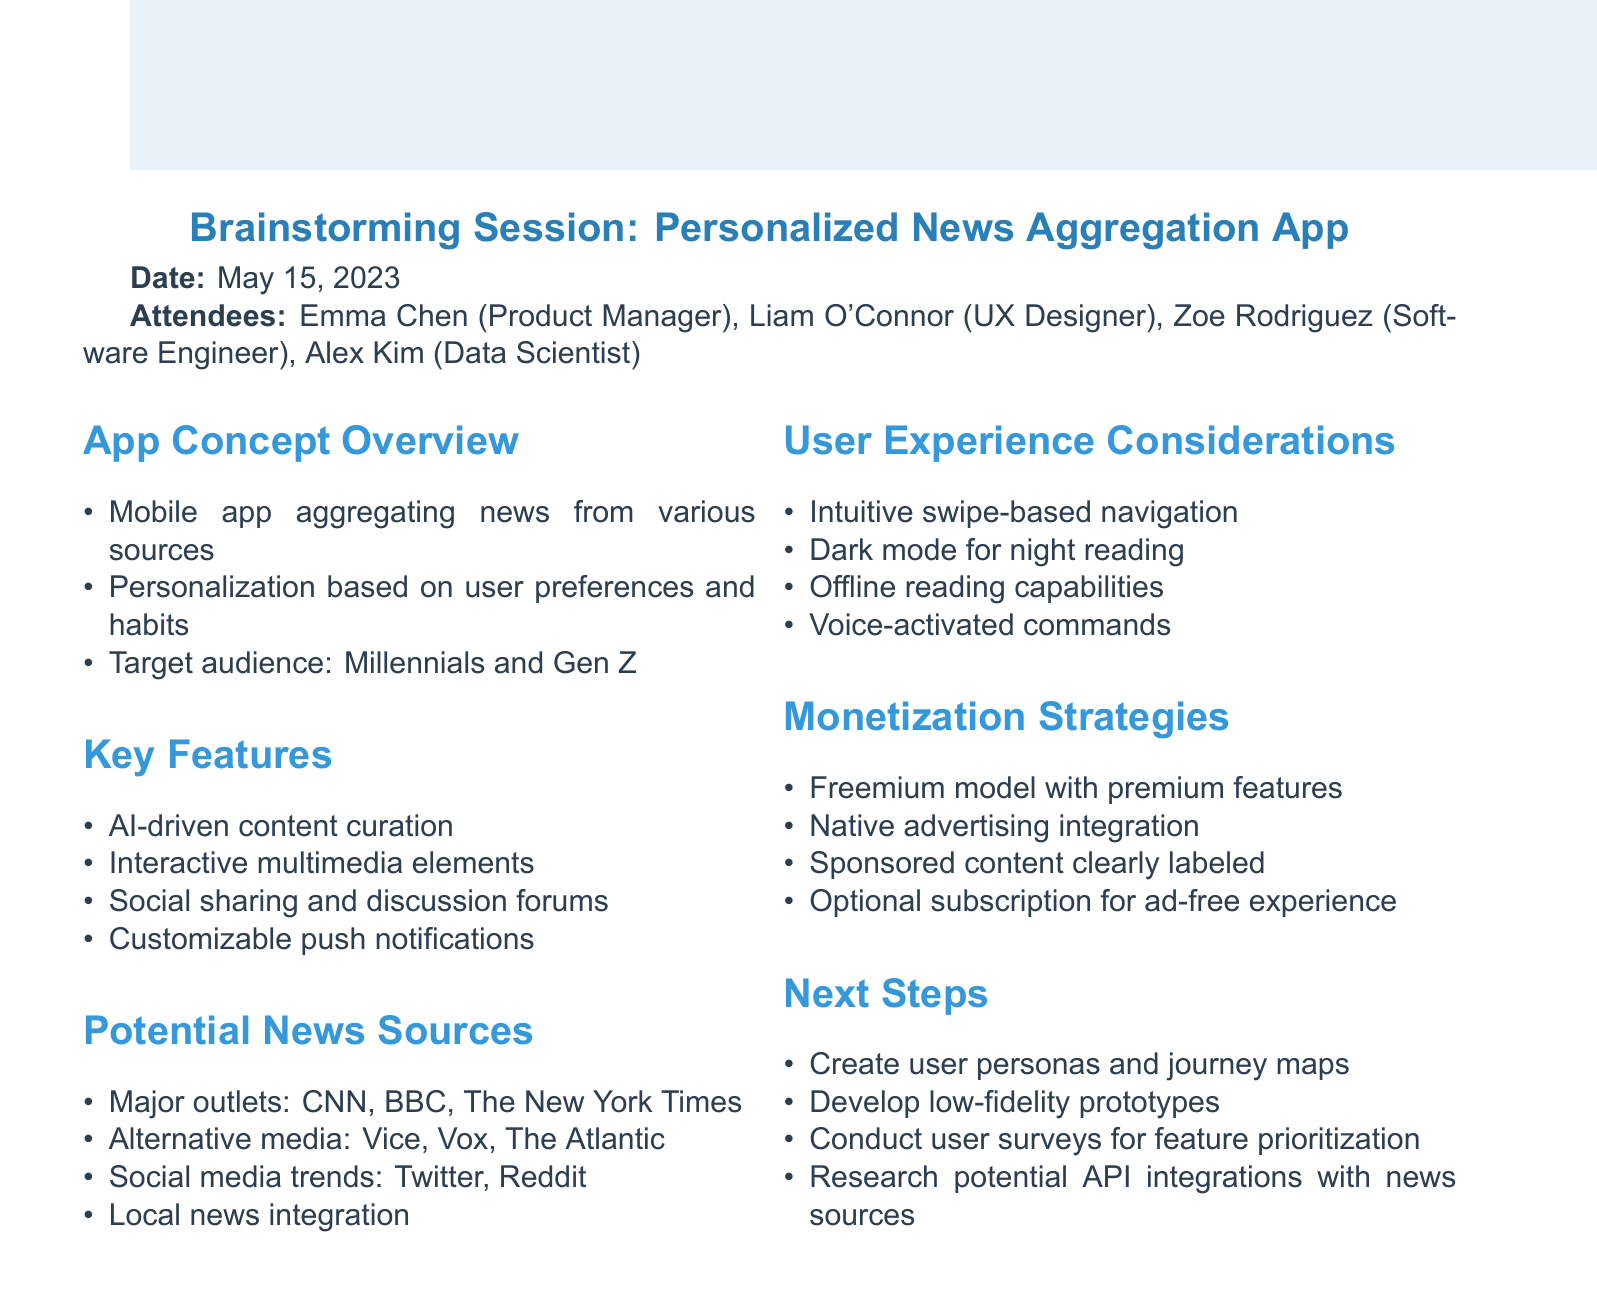What is the date of the meeting? The date of the meeting is stated at the beginning of the document.
Answer: May 15, 2023 Who is the Product Manager? The document lists the attendees along with their roles.
Answer: Emma Chen What is the target audience for the app? The document specifies the target audience in the Overview section.
Answer: Millennials and Gen Z What feature involves social interaction? The Key Features section mentions this feature specifically.
Answer: Social sharing and discussion forums Which major news outlet is mentioned in the Potential News Sources? The document lists a few news sources considered for the app.
Answer: CNN What is one UX consideration related to nighttime use? The User Experience section highlights this specific feature.
Answer: Dark mode for night reading What monetization strategy includes an optional subscription? The Monetization Strategies section describes this approach.
Answer: Optional subscription for ad-free experience What is the next step involving user insights? The Next Steps section contains this activity to improve the app's features.
Answer: Conduct user surveys for feature prioritization What type of app is being discussed? The document's title and overview give this information.
Answer: Personalized News Aggregation App 